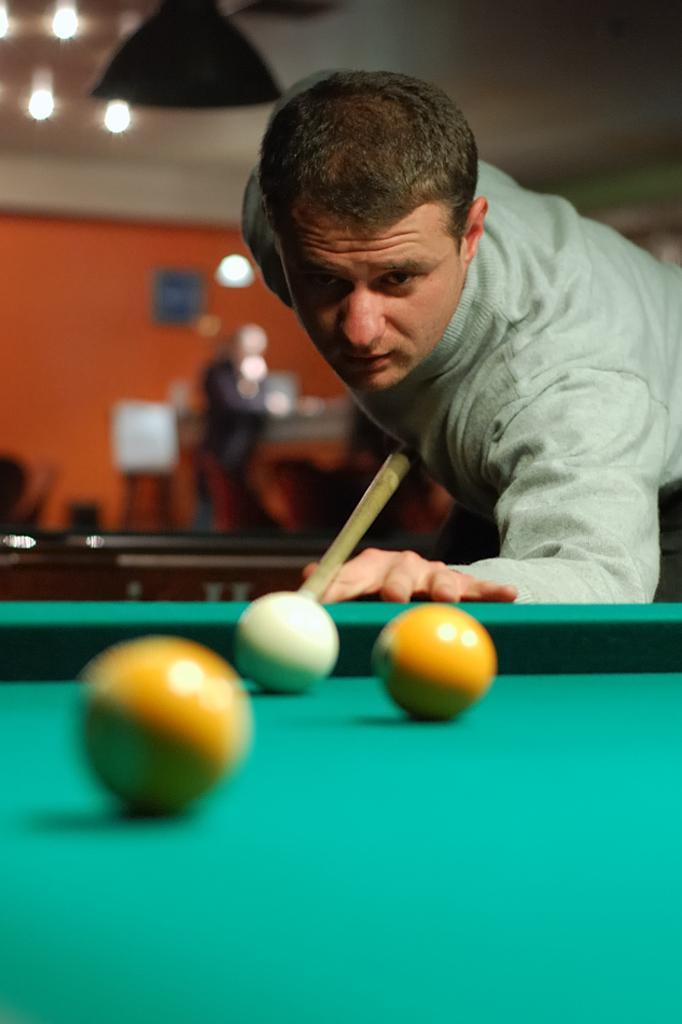Please provide a concise description of this image. As we can see in the image there is a man playing billiards. 